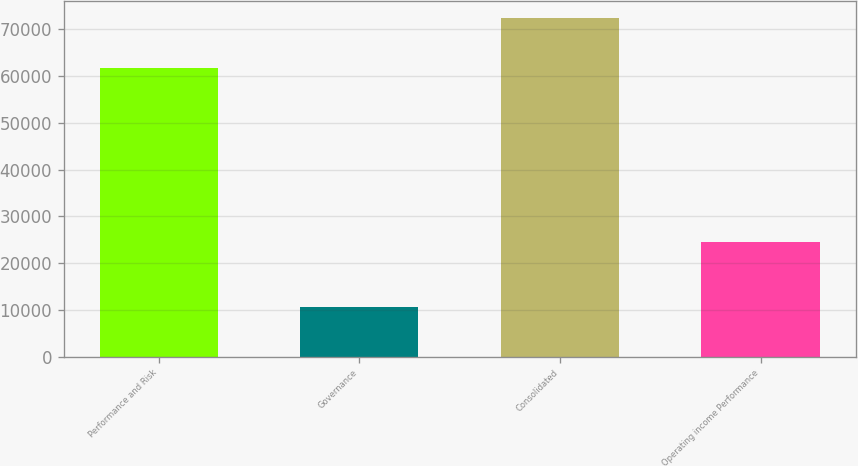Convert chart. <chart><loc_0><loc_0><loc_500><loc_500><bar_chart><fcel>Performance and Risk<fcel>Governance<fcel>Consolidated<fcel>Operating income Performance<nl><fcel>61841<fcel>10683<fcel>72524<fcel>24601<nl></chart> 